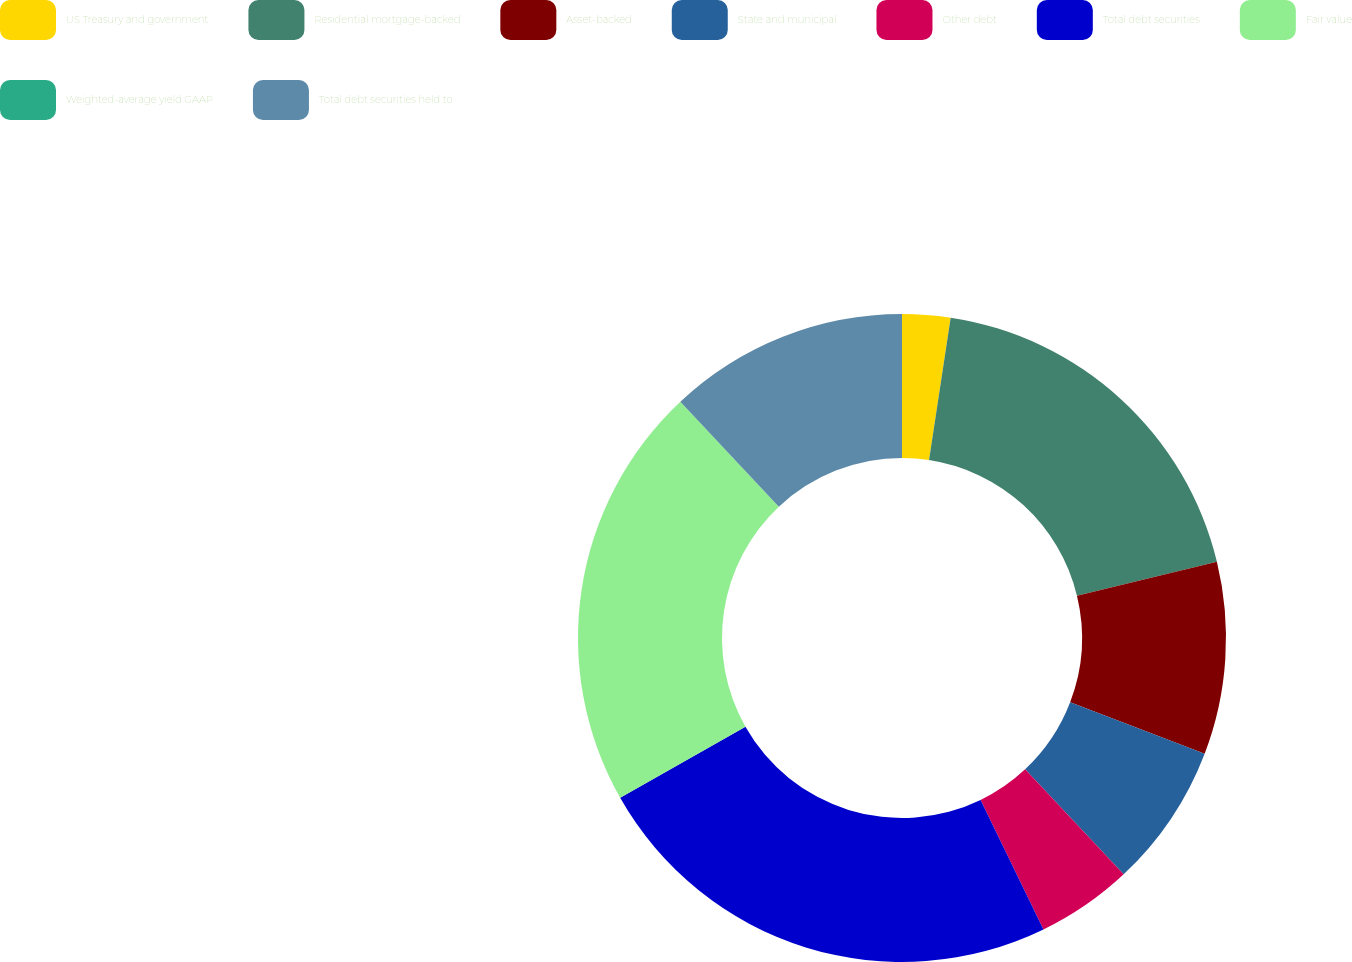Convert chart to OTSL. <chart><loc_0><loc_0><loc_500><loc_500><pie_chart><fcel>US Treasury and government<fcel>Residential mortgage-backed<fcel>Asset-backed<fcel>State and municipal<fcel>Other debt<fcel>Total debt securities<fcel>Fair value<fcel>Weighted-average yield GAAP<fcel>Total debt securities held to<nl><fcel>2.4%<fcel>18.82%<fcel>9.59%<fcel>7.2%<fcel>4.8%<fcel>23.98%<fcel>21.22%<fcel>0.0%<fcel>11.99%<nl></chart> 